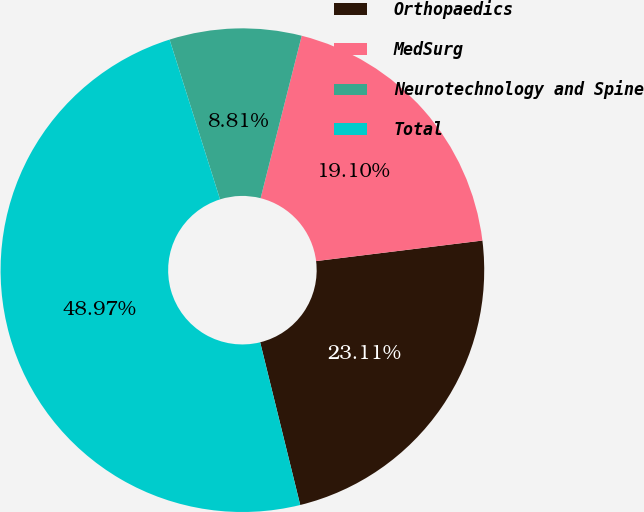Convert chart. <chart><loc_0><loc_0><loc_500><loc_500><pie_chart><fcel>Orthopaedics<fcel>MedSurg<fcel>Neurotechnology and Spine<fcel>Total<nl><fcel>23.11%<fcel>19.1%<fcel>8.81%<fcel>48.97%<nl></chart> 